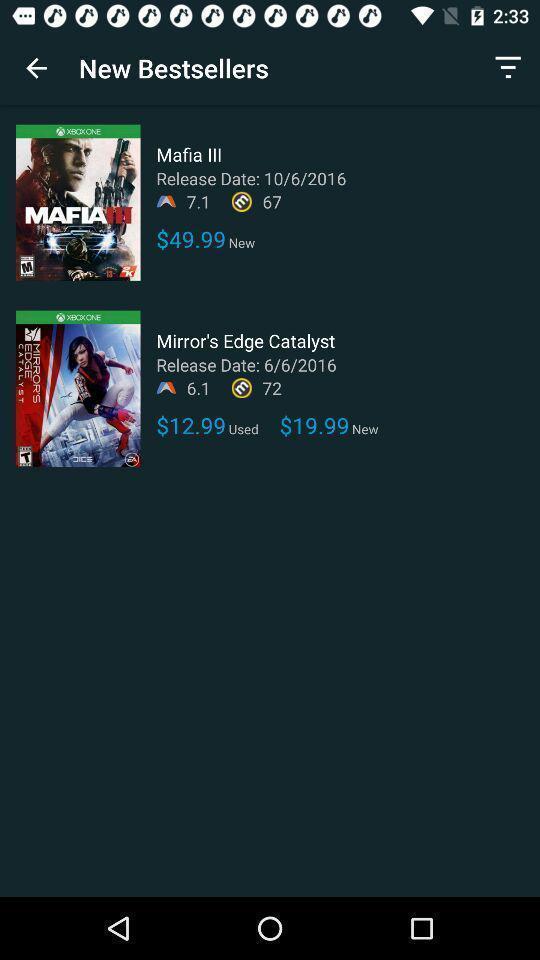Describe this image in words. Video game movies showing in this page. 